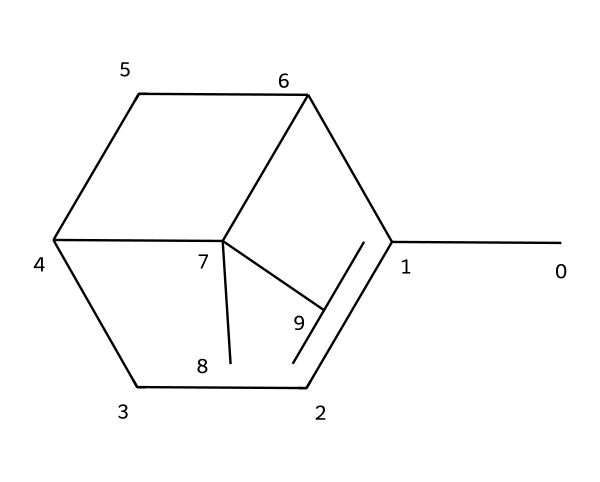What is the molecular formula of pinene? To determine the molecular formula, we identify and count all carbon (C) and hydrogen (H) atoms in the provided SMILES structure. There are 10 carbon atoms and 16 hydrogen atoms. Therefore, the molecular formula is C10H16.
Answer: C10H16 How many rings are present in pinene's structure? Looking at the SMILES representation, we see the presence of two numbers (1 and 2) indicating ring closures. Thus, there are two rings in the structure.
Answer: 2 Is pinene a saturated or unsaturated compound? By analyzing the structure, we observe the presence of double bonds (due to the angular arrangement and absence of single hydrogen atoms in some locations), indicating that it is unsaturated.
Answer: unsaturated What type of compound is pinene classified as? Pinene belongs to the class of terpenes, which are characterized by their hydrocarbon structures derived primarily from isoprene units.
Answer: terpene What is the boiling point trend for compounds like pinene based on structural features? Compounds like pinene, due to their hydrocarbon nature, usually have relatively low boiling points compared to more complex or polar molecules. This is due to the presence of weak van der Waals forces among similar molecules.
Answer: low Why is pinene commonly found in pine trees? Pinene serves various ecological functions, including pheromone signaling among insects and acting as a defense mechanism for the trees themselves. Its presence is essential for the tree’s survival.
Answer: defense mechanism 